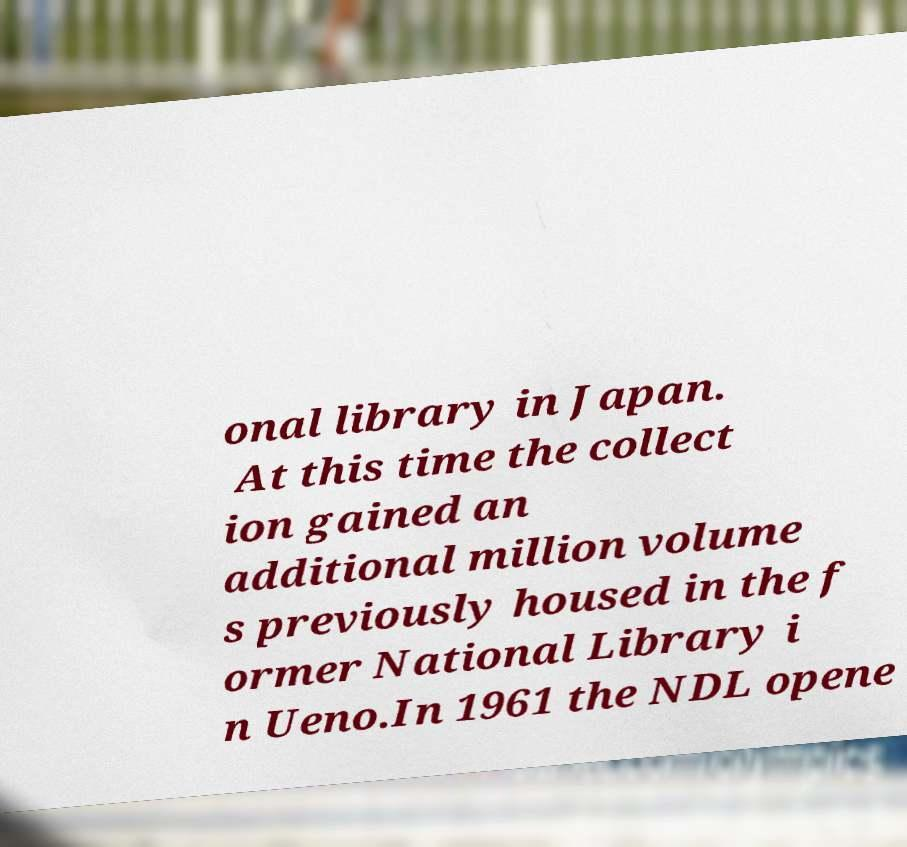I need the written content from this picture converted into text. Can you do that? onal library in Japan. At this time the collect ion gained an additional million volume s previously housed in the f ormer National Library i n Ueno.In 1961 the NDL opene 